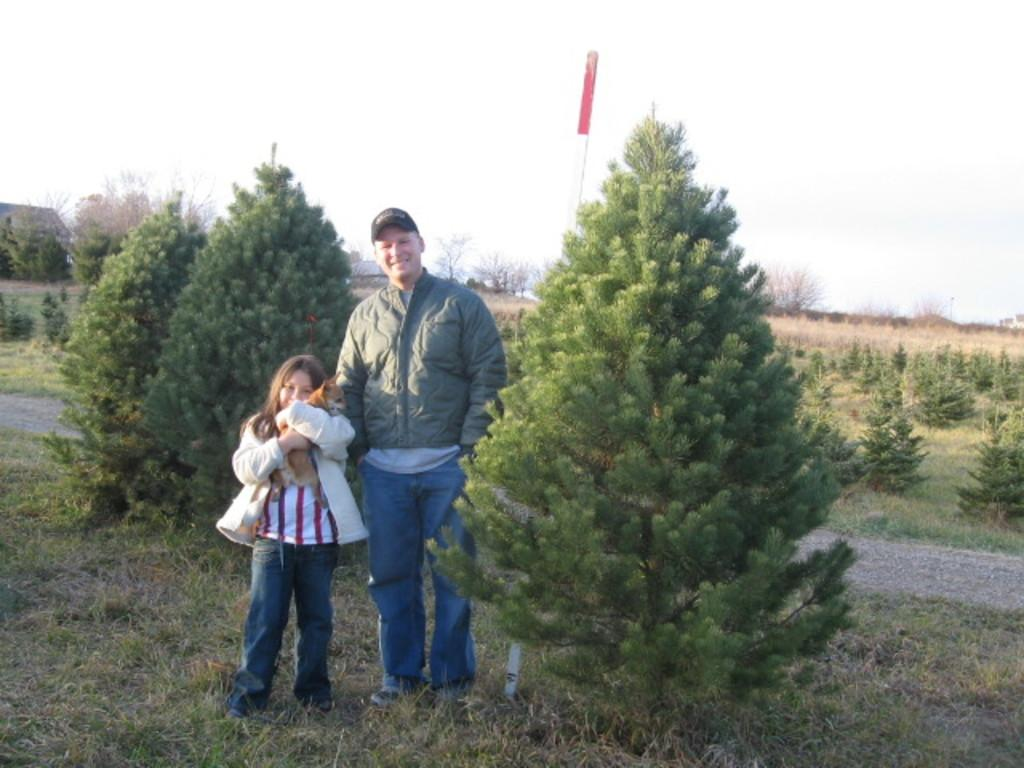Who is present in the image? There is a person and a girl in the image. What is the girl doing in the image? The girl is holding a dog in the image. What type of surface is visible in the image? There is grass in the image. What other natural elements can be seen in the image? There are plants in the image. What object is present in the image that is not a living being? There is a board in the image. What can be seen in the sky in the image? The sky is visible in the image. What are the person and the girl wearing in the image? The person and the girl are wearing jackets in the image. How many pizzas are being served on the map in the image? There is no map or pizzas present in the image. What is the aftermath of the event depicted in the image? There is no event depicted in the image, so it's not possible to determine the aftermath. 